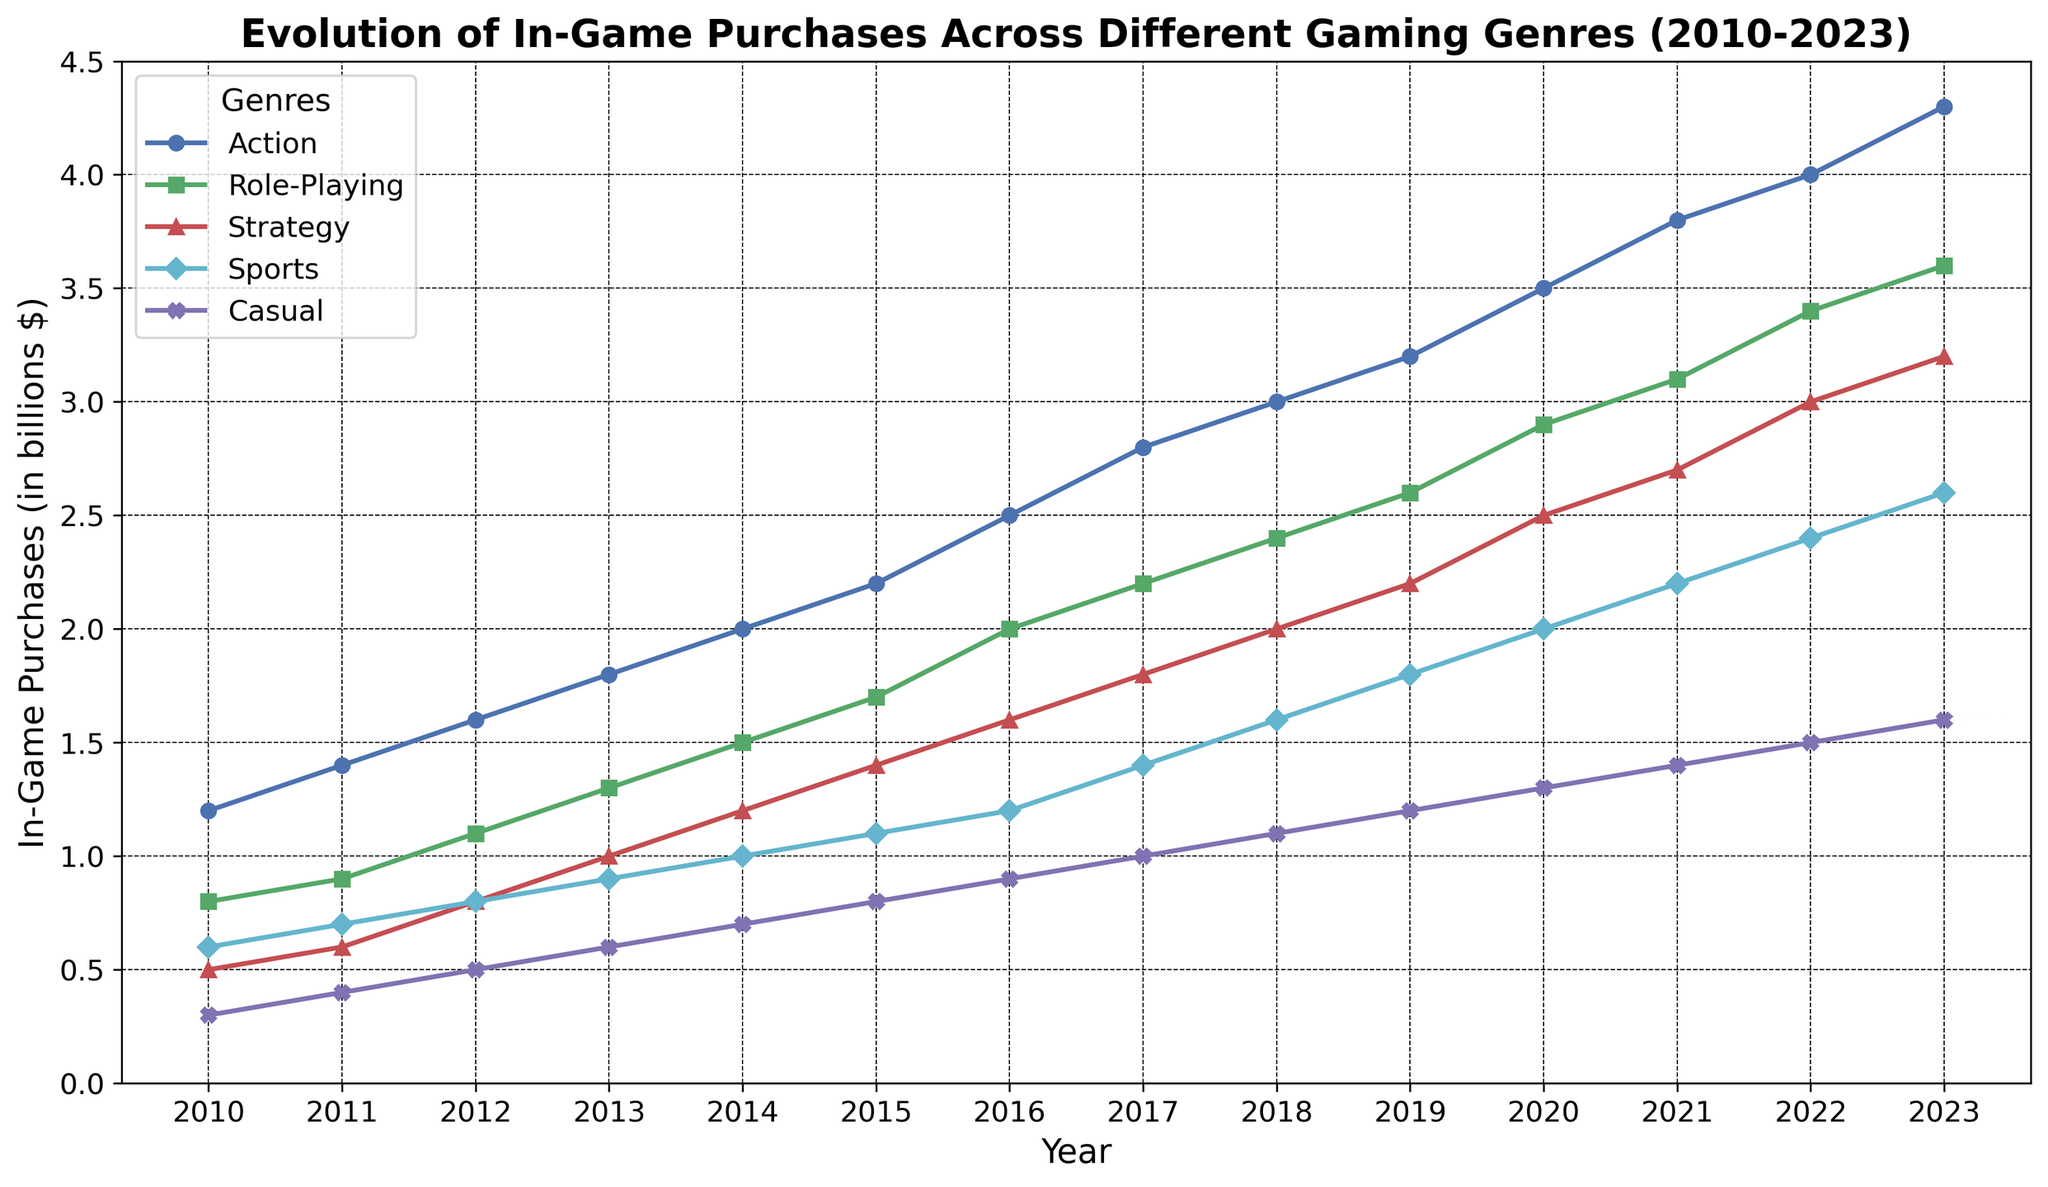What year did Role-Playing games surpass 2 billion in in-game purchases? By observing the line for Role-Playing games, we see it crosses the 2 billion mark between 2015 and 2016.
Answer: 2016 Which genre had the highest increase in in-game purchases from 2010 to 2023? Calculate the increase for each genre: Action (4.3-1.2), Role-Playing (3.6-0.8), Strategy (3.2-0.5), Sports (2.6-0.6), Casual (1.6-0.3). Action had the highest increase.
Answer: Action Between which years did Strategy games see their largest single-year growth? Examine the year-over-year increments for Strategy games. The largest jump is from 2021 (2.7) to 2022 (3.0).
Answer: 2021-2022 Which genre has consistently shown growth year-over-year without any plateau or drop? By reviewing each line trend, we see that all genres show consistent growth without any plateaus or declines.
Answer: All genres What is the average in-game purchase value for Casual games across the given period? Sum the values and divide by the number of years: (0.3+0.4+0.5+0.6+0.7+0.8+0.9+1.0+1.1+1.2+1.3+1.4+1.5+1.6)/14. This results in (14.3)/14.
Answer: 1.02 Which genre showed the closest growth to Role-Playing games in 2023? Compare the values of other genres with Role-Playing in 2023. Strategy (3.2) is closest to Role-Playing (3.6).
Answer: Strategy How much did Sports games increase in in-game purchases from 2010 to 2015? Subtract the value in 2010 from that in 2015: (1.1 - 0.6).
Answer: 0.5 What is the combined in-game purchase total for Casual and Role-Playing games in 2021? Add the values of Casual (1.4) and Role-Playing (3.1) in 2021.
Answer: 4.5 